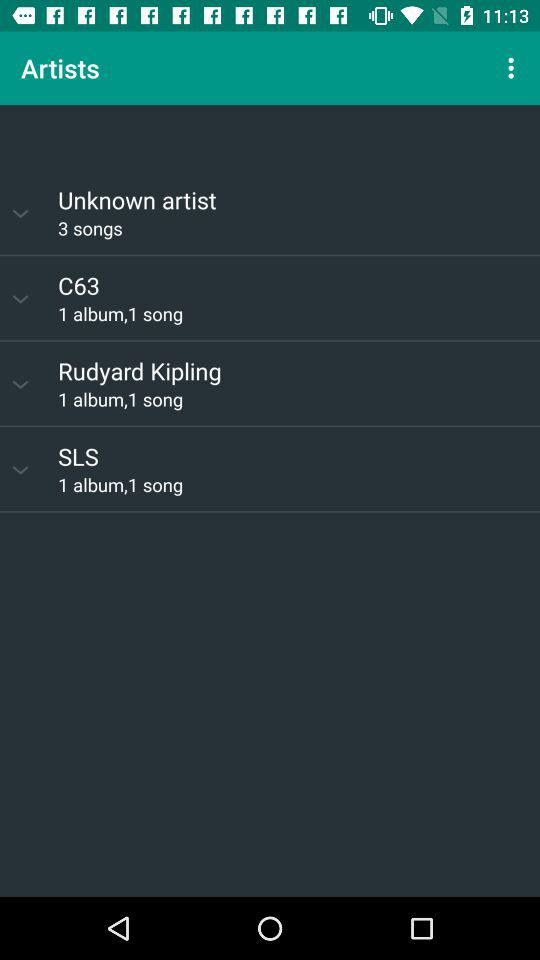How many available albums are by "C63"? There is 1 available album by "C63". 